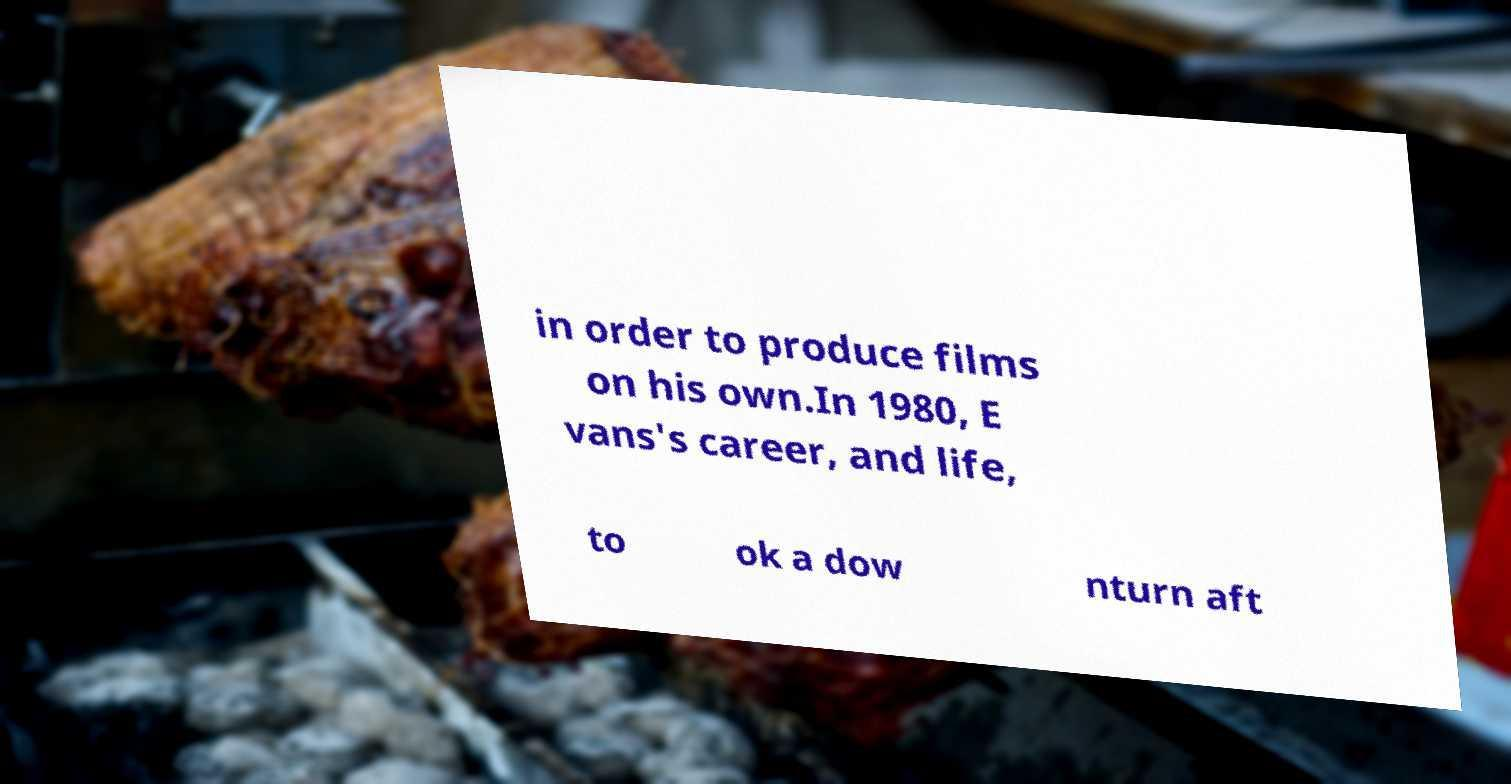Please read and relay the text visible in this image. What does it say? in order to produce films on his own.In 1980, E vans's career, and life, to ok a dow nturn aft 